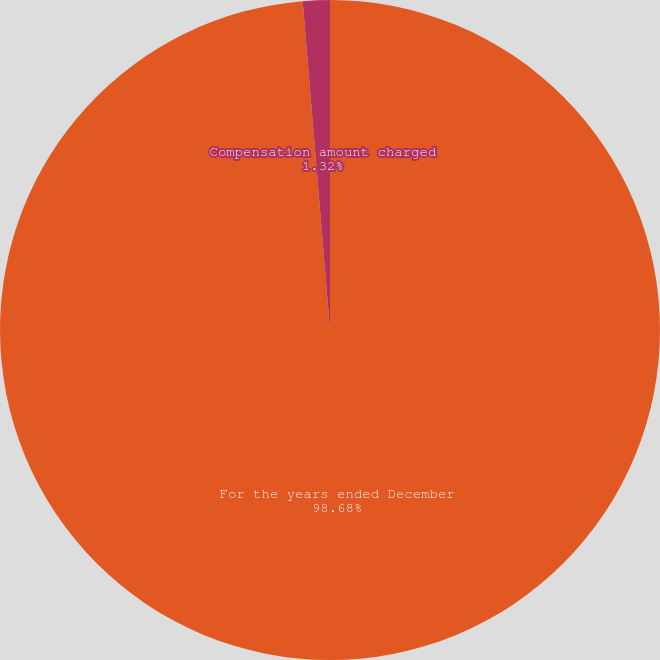Convert chart to OTSL. <chart><loc_0><loc_0><loc_500><loc_500><pie_chart><fcel>For the years ended December<fcel>Compensation amount charged<nl><fcel>98.68%<fcel>1.32%<nl></chart> 